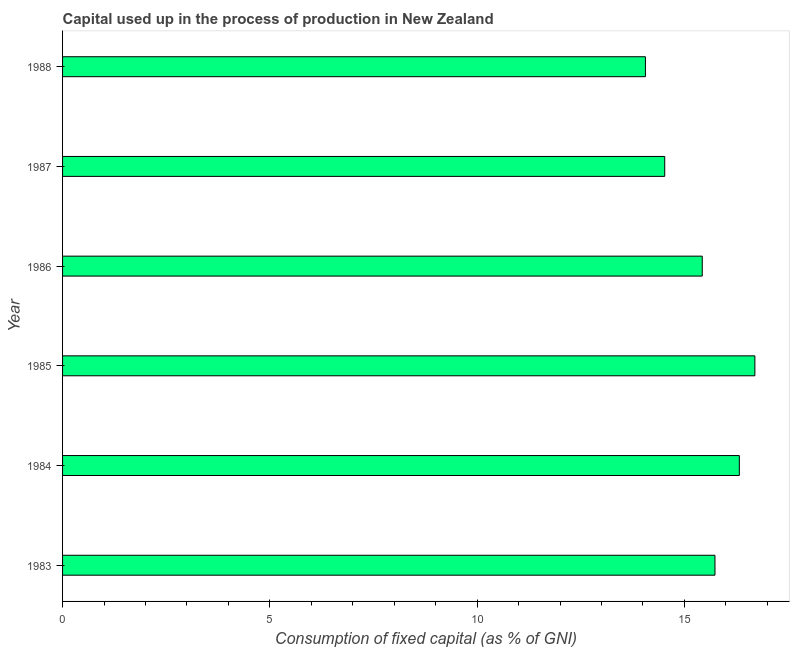Does the graph contain any zero values?
Ensure brevity in your answer.  No. Does the graph contain grids?
Your answer should be compact. No. What is the title of the graph?
Your response must be concise. Capital used up in the process of production in New Zealand. What is the label or title of the X-axis?
Make the answer very short. Consumption of fixed capital (as % of GNI). What is the label or title of the Y-axis?
Offer a very short reply. Year. What is the consumption of fixed capital in 1987?
Provide a succinct answer. 14.53. Across all years, what is the maximum consumption of fixed capital?
Provide a short and direct response. 16.7. Across all years, what is the minimum consumption of fixed capital?
Ensure brevity in your answer.  14.06. In which year was the consumption of fixed capital maximum?
Offer a very short reply. 1985. In which year was the consumption of fixed capital minimum?
Your answer should be very brief. 1988. What is the sum of the consumption of fixed capital?
Your answer should be compact. 92.78. What is the difference between the consumption of fixed capital in 1983 and 1988?
Give a very brief answer. 1.68. What is the average consumption of fixed capital per year?
Make the answer very short. 15.46. What is the median consumption of fixed capital?
Keep it short and to the point. 15.58. What is the ratio of the consumption of fixed capital in 1983 to that in 1988?
Give a very brief answer. 1.12. Is the sum of the consumption of fixed capital in 1986 and 1987 greater than the maximum consumption of fixed capital across all years?
Your response must be concise. Yes. What is the difference between the highest and the lowest consumption of fixed capital?
Give a very brief answer. 2.64. How many bars are there?
Offer a terse response. 6. Are all the bars in the graph horizontal?
Ensure brevity in your answer.  Yes. What is the Consumption of fixed capital (as % of GNI) in 1983?
Your answer should be very brief. 15.74. What is the Consumption of fixed capital (as % of GNI) in 1984?
Offer a terse response. 16.33. What is the Consumption of fixed capital (as % of GNI) of 1985?
Your answer should be compact. 16.7. What is the Consumption of fixed capital (as % of GNI) of 1986?
Offer a very short reply. 15.43. What is the Consumption of fixed capital (as % of GNI) in 1987?
Offer a very short reply. 14.53. What is the Consumption of fixed capital (as % of GNI) in 1988?
Provide a short and direct response. 14.06. What is the difference between the Consumption of fixed capital (as % of GNI) in 1983 and 1984?
Your answer should be compact. -0.59. What is the difference between the Consumption of fixed capital (as % of GNI) in 1983 and 1985?
Your answer should be very brief. -0.96. What is the difference between the Consumption of fixed capital (as % of GNI) in 1983 and 1986?
Your response must be concise. 0.31. What is the difference between the Consumption of fixed capital (as % of GNI) in 1983 and 1987?
Ensure brevity in your answer.  1.21. What is the difference between the Consumption of fixed capital (as % of GNI) in 1983 and 1988?
Provide a short and direct response. 1.68. What is the difference between the Consumption of fixed capital (as % of GNI) in 1984 and 1985?
Offer a very short reply. -0.38. What is the difference between the Consumption of fixed capital (as % of GNI) in 1984 and 1986?
Your answer should be compact. 0.89. What is the difference between the Consumption of fixed capital (as % of GNI) in 1984 and 1987?
Offer a very short reply. 1.8. What is the difference between the Consumption of fixed capital (as % of GNI) in 1984 and 1988?
Your response must be concise. 2.27. What is the difference between the Consumption of fixed capital (as % of GNI) in 1985 and 1986?
Provide a succinct answer. 1.27. What is the difference between the Consumption of fixed capital (as % of GNI) in 1985 and 1987?
Offer a very short reply. 2.17. What is the difference between the Consumption of fixed capital (as % of GNI) in 1985 and 1988?
Your answer should be very brief. 2.64. What is the difference between the Consumption of fixed capital (as % of GNI) in 1986 and 1987?
Your answer should be very brief. 0.91. What is the difference between the Consumption of fixed capital (as % of GNI) in 1986 and 1988?
Ensure brevity in your answer.  1.37. What is the difference between the Consumption of fixed capital (as % of GNI) in 1987 and 1988?
Your response must be concise. 0.47. What is the ratio of the Consumption of fixed capital (as % of GNI) in 1983 to that in 1984?
Offer a terse response. 0.96. What is the ratio of the Consumption of fixed capital (as % of GNI) in 1983 to that in 1985?
Offer a terse response. 0.94. What is the ratio of the Consumption of fixed capital (as % of GNI) in 1983 to that in 1987?
Ensure brevity in your answer.  1.08. What is the ratio of the Consumption of fixed capital (as % of GNI) in 1983 to that in 1988?
Ensure brevity in your answer.  1.12. What is the ratio of the Consumption of fixed capital (as % of GNI) in 1984 to that in 1985?
Ensure brevity in your answer.  0.98. What is the ratio of the Consumption of fixed capital (as % of GNI) in 1984 to that in 1986?
Give a very brief answer. 1.06. What is the ratio of the Consumption of fixed capital (as % of GNI) in 1984 to that in 1987?
Your answer should be compact. 1.12. What is the ratio of the Consumption of fixed capital (as % of GNI) in 1984 to that in 1988?
Your response must be concise. 1.16. What is the ratio of the Consumption of fixed capital (as % of GNI) in 1985 to that in 1986?
Keep it short and to the point. 1.08. What is the ratio of the Consumption of fixed capital (as % of GNI) in 1985 to that in 1987?
Make the answer very short. 1.15. What is the ratio of the Consumption of fixed capital (as % of GNI) in 1985 to that in 1988?
Offer a very short reply. 1.19. What is the ratio of the Consumption of fixed capital (as % of GNI) in 1986 to that in 1987?
Ensure brevity in your answer.  1.06. What is the ratio of the Consumption of fixed capital (as % of GNI) in 1986 to that in 1988?
Your answer should be very brief. 1.1. What is the ratio of the Consumption of fixed capital (as % of GNI) in 1987 to that in 1988?
Provide a short and direct response. 1.03. 